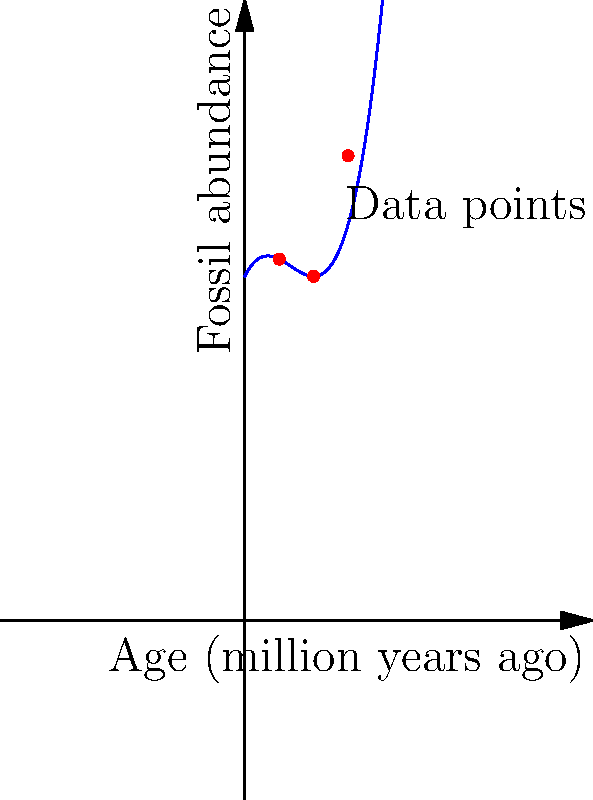A Romanian paleontologist has collected fossil abundance data from a specific geological formation. The data points are plotted on the graph, showing fossil abundance against age. Which degree polynomial would best fit this data, and what geological insight might this provide about the depositional environment over time? To determine the best-fitting polynomial and interpret the geological implications, let's follow these steps:

1. Observe the data points: We see three red dots on the graph, representing fossil abundance at different ages.

2. Analyze the curve shape: The blue line shows a curve that fits these points. It has one clear minimum and increases on both sides, suggesting a higher-degree polynomial.

3. Determine the polynomial degree:
   - A linear (1st degree) polynomial would be a straight line, which clearly doesn't fit.
   - A quadratic (2nd degree) polynomial would have one turn (parabola), which also doesn't fit well.
   - A cubic (3rd degree) polynomial can have two turns, which matches the shape we see.

4. Interpret the curve:
   - The curve starts high, decreases to a minimum, then increases again.
   - In geological terms, this could represent:
     a) An initial period of high fossil abundance (possibly favorable conditions)
     b) A period of decline (possibly changing environmental conditions)
     c) A subsequent increase in fossil abundance (return to favorable conditions)

5. Geological insight:
   - This pattern might indicate cyclical changes in the depositional environment.
   - Factors like sea level changes, climate fluctuations, or tectonic activity could cause such variations in fossil abundance over time.

6. Relevance to Romanian geology:
   - This analysis method could be applied to study fossil-rich formations in Romania, such as those in the Carpathian Mountains or the Transylvanian Basin.
Answer: 3rd degree polynomial; suggests cyclical changes in depositional environment 